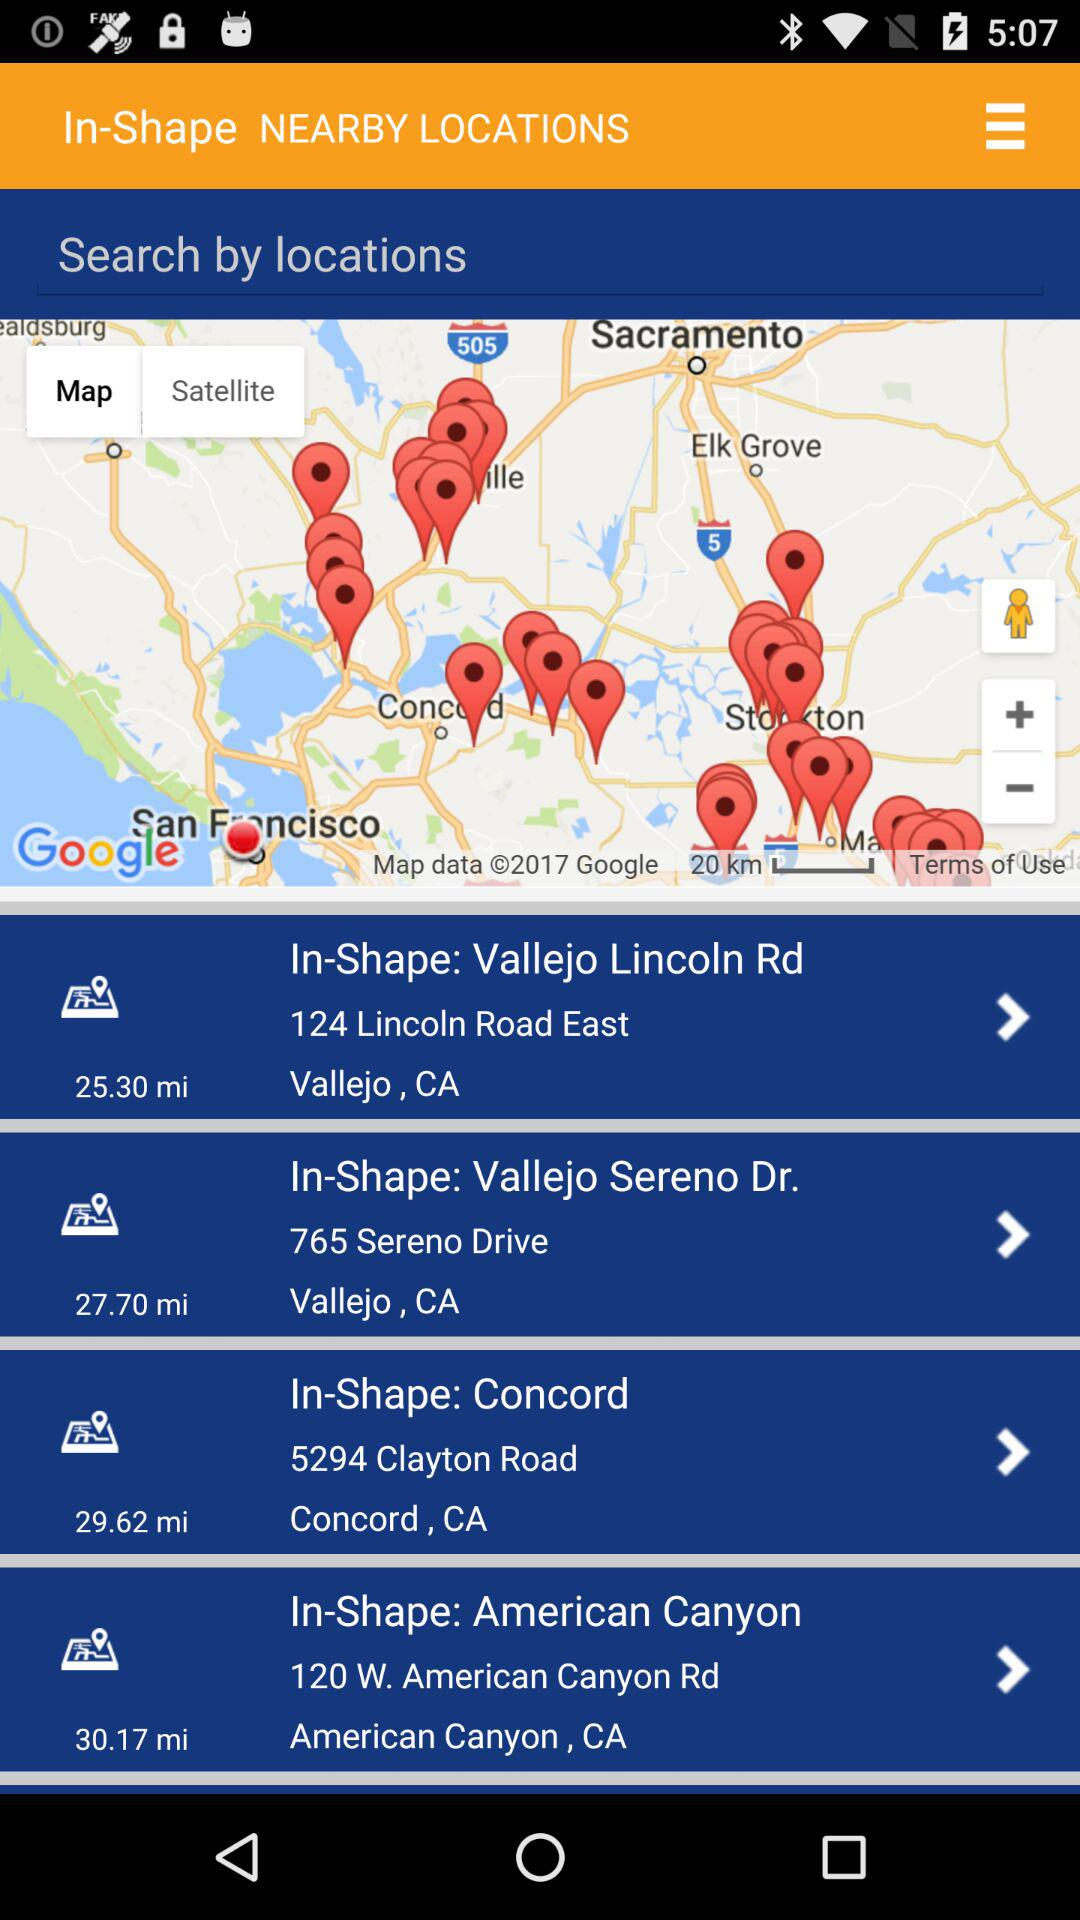What is the address of In-Shape: American Canyon? The address of In-Shape: American Canyon is 120 W. American Canyon Rd, American Canyon, CA. 